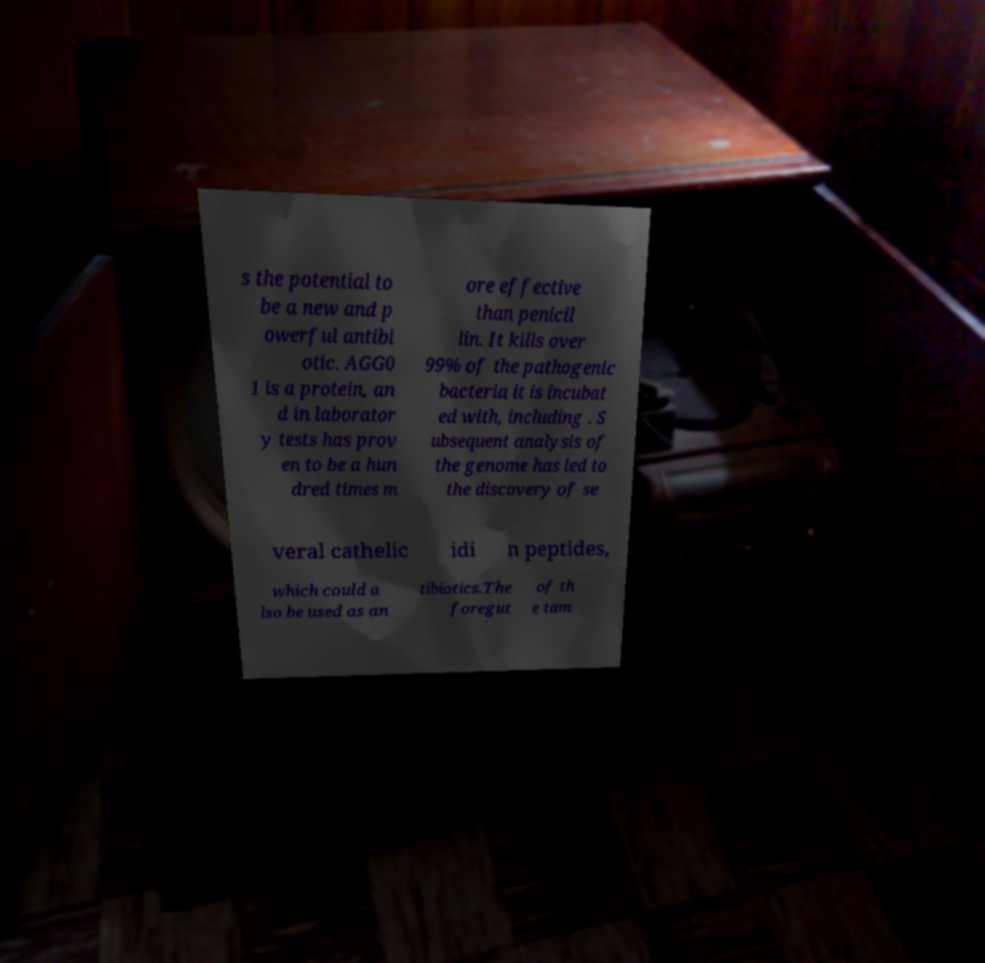Can you accurately transcribe the text from the provided image for me? s the potential to be a new and p owerful antibi otic. AGG0 1 is a protein, an d in laborator y tests has prov en to be a hun dred times m ore effective than penicil lin. It kills over 99% of the pathogenic bacteria it is incubat ed with, including . S ubsequent analysis of the genome has led to the discovery of se veral cathelic idi n peptides, which could a lso be used as an tibiotics.The foregut of th e tam 